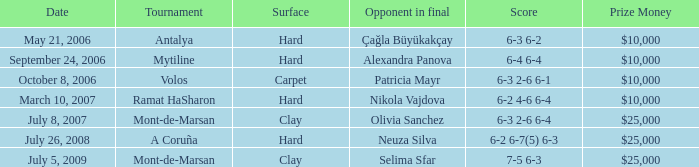What is the score of the hard court Ramat Hasharon tournament? 6-2 4-6 6-4. Can you give me this table as a dict? {'header': ['Date', 'Tournament', 'Surface', 'Opponent in final', 'Score', 'Prize Money'], 'rows': [['May 21, 2006', 'Antalya', 'Hard', 'Çağla Büyükakçay', '6-3 6-2', '$10,000'], ['September 24, 2006', 'Mytiline', 'Hard', 'Alexandra Panova', '6-4 6-4', '$10,000'], ['October 8, 2006', 'Volos', 'Carpet', 'Patricia Mayr', '6-3 2-6 6-1', '$10,000'], ['March 10, 2007', 'Ramat HaSharon', 'Hard', 'Nikola Vajdova', '6-2 4-6 6-4', '$10,000'], ['July 8, 2007', 'Mont-de-Marsan', 'Clay', 'Olivia Sanchez', '6-3 2-6 6-4', '$25,000'], ['July 26, 2008', 'A Coruña', 'Hard', 'Neuza Silva', '6-2 6-7(5) 6-3', '$25,000'], ['July 5, 2009', 'Mont-de-Marsan', 'Clay', 'Selima Sfar', '7-5 6-3', '$25,000']]} 